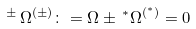<formula> <loc_0><loc_0><loc_500><loc_500>\, ^ { \pm } \, \Omega ^ { ( \pm ) } \colon = \Omega \pm \, ^ { * } \Omega ^ { ( ^ { * } ) } = 0</formula> 